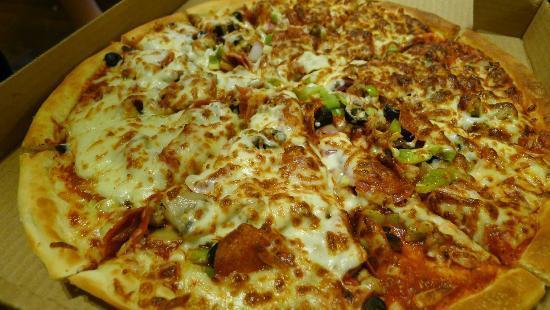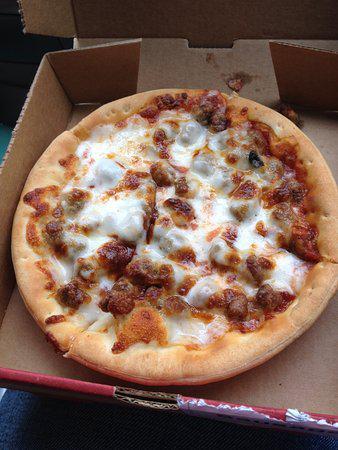The first image is the image on the left, the second image is the image on the right. Assess this claim about the two images: "All pizzas pictured are whole without any pieces missing or removed.". Correct or not? Answer yes or no. Yes. The first image is the image on the left, the second image is the image on the right. Assess this claim about the two images: "One image shows one sliced pepperoni pizza with all the slices still lying flat, and the other image shows a pepperoni pizza with a slice that is out of place and off the surface.". Correct or not? Answer yes or no. No. 